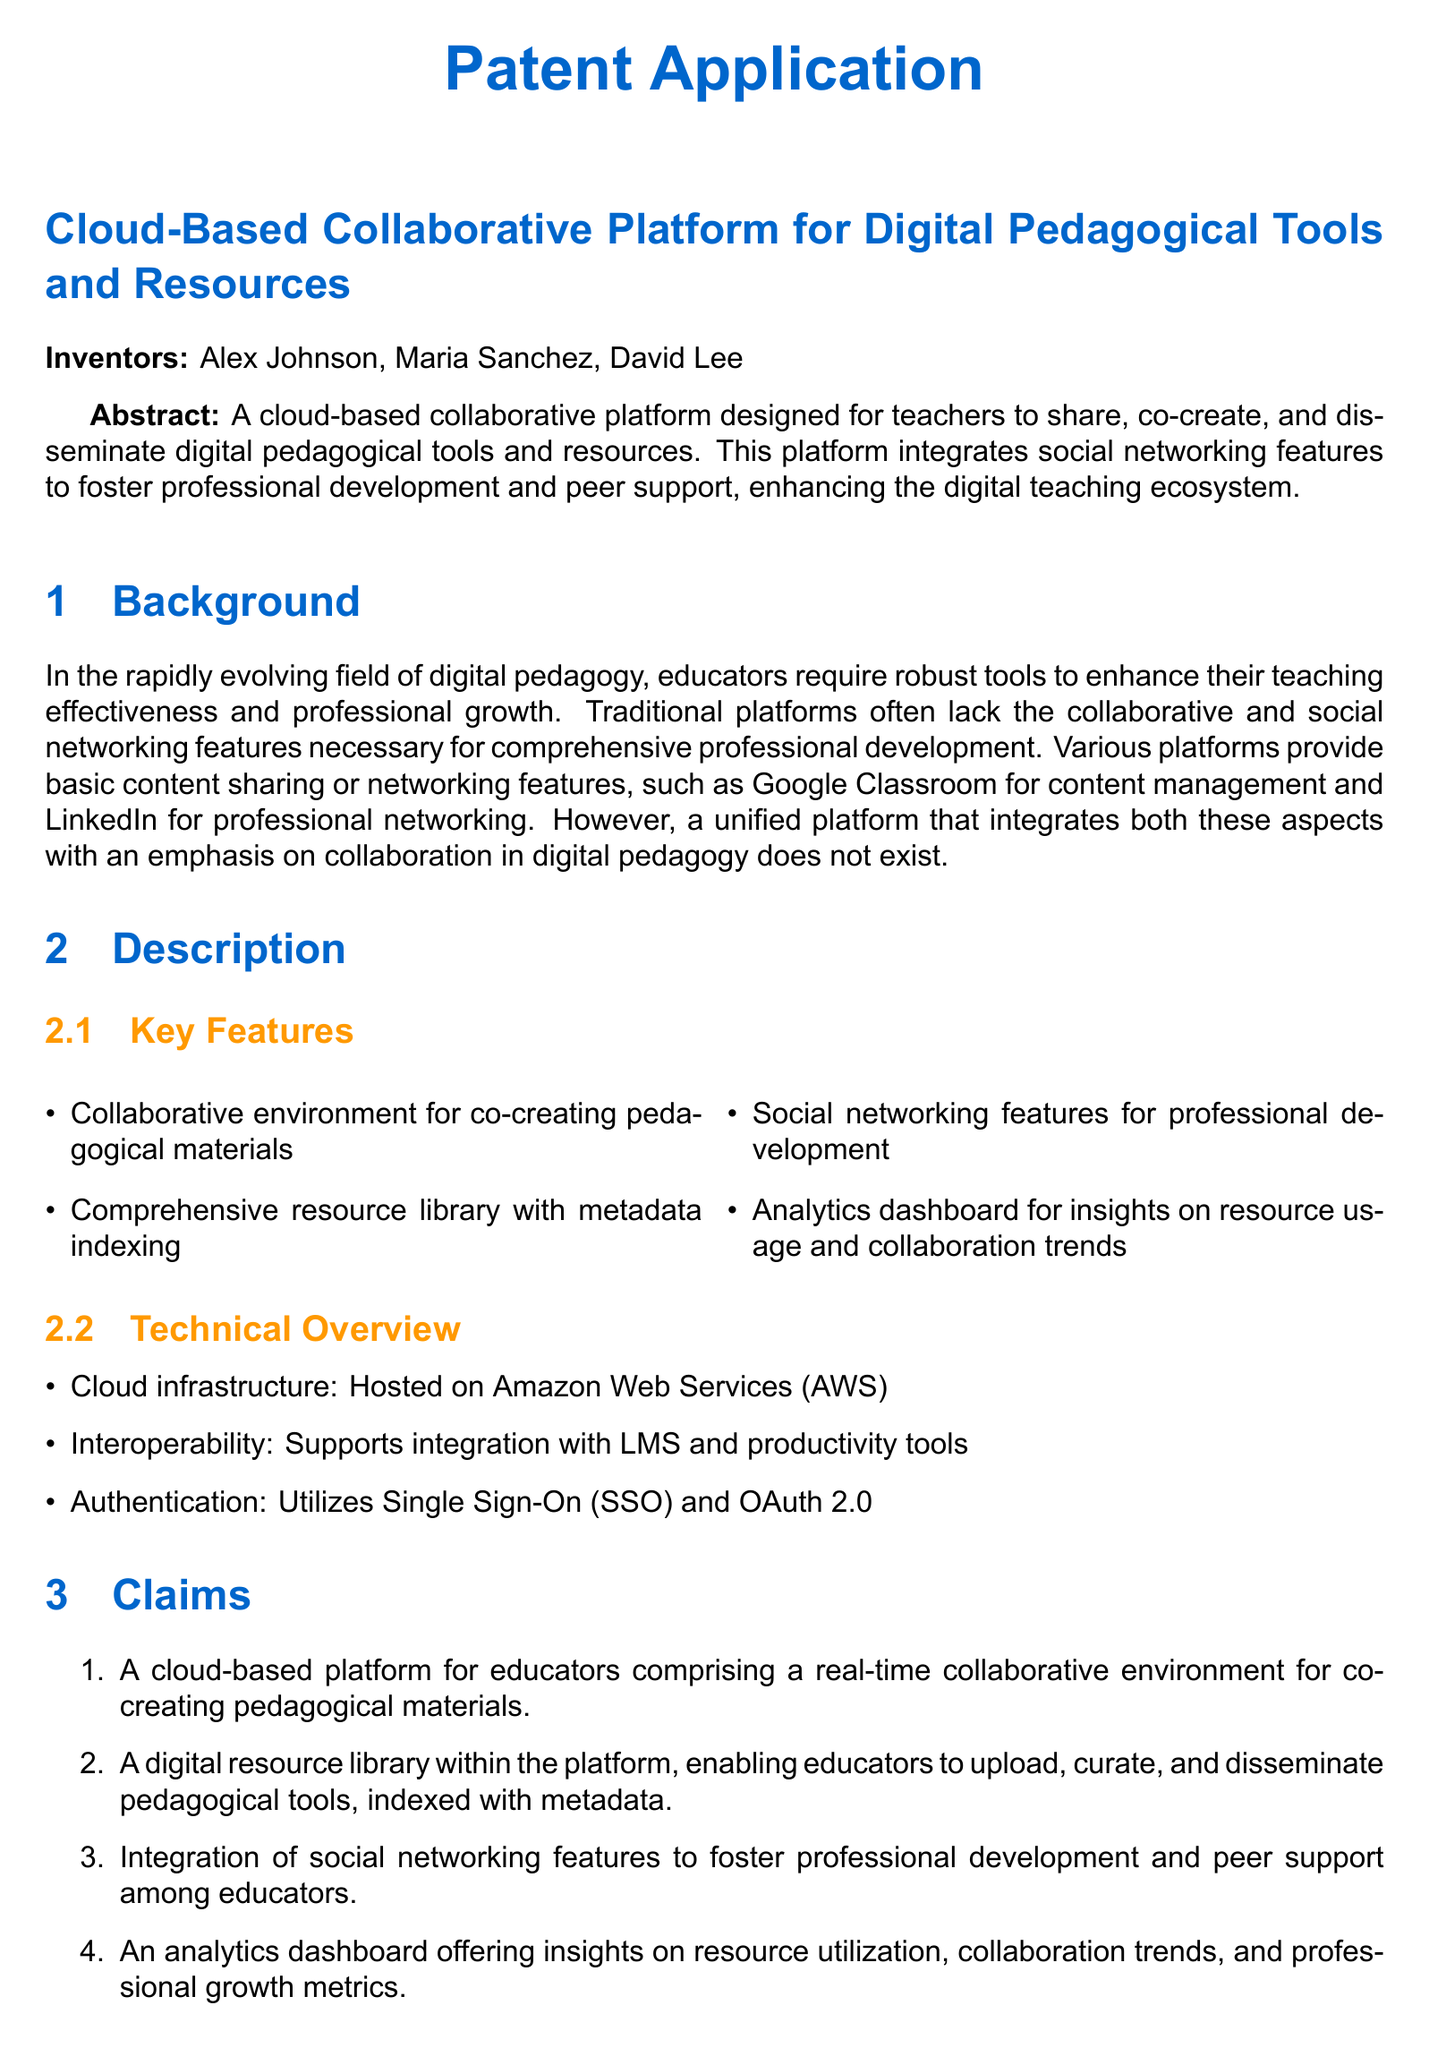What is the title of the patent application? The title of the patent application is the primary subject outlined at the beginning of the document.
Answer: Cloud-Based Collaborative Platform for Digital Pedagogical Tools and Resources Who are the inventors listed in the patent application? The inventors are specifically named in the introductory section of the document.
Answer: Alex Johnson, Maria Sanchez, David Lee What cloud infrastructure is mentioned in the technical overview? The document specifies the hosting solution for the platform in the technical overview.
Answer: Amazon Web Services (AWS) What features are included in the analytics dashboard? The analytics dashboard is described in the claims section, focusing on its insights.
Answer: Insights on resource utilization, collaboration trends, and professional growth metrics How many key features are listed in the description? The number of key features can be found in the key features subsection within the document.
Answer: Four What is the purpose of the social networking features? The purpose is inferred from the description of integration with professional development and peer support, found in the key features.
Answer: Foster professional development and peer support What type of authentication is mentioned for the platform? The specific authentication methods used by the platform are detailed in the technical overview.
Answer: Single Sign-On (SSO) and OAuth 2.0 What does the collaborative environment allow educators to do? The document specifies the functionality of the collaborative environment in the claims section.
Answer: Co-creating pedagogical materials 